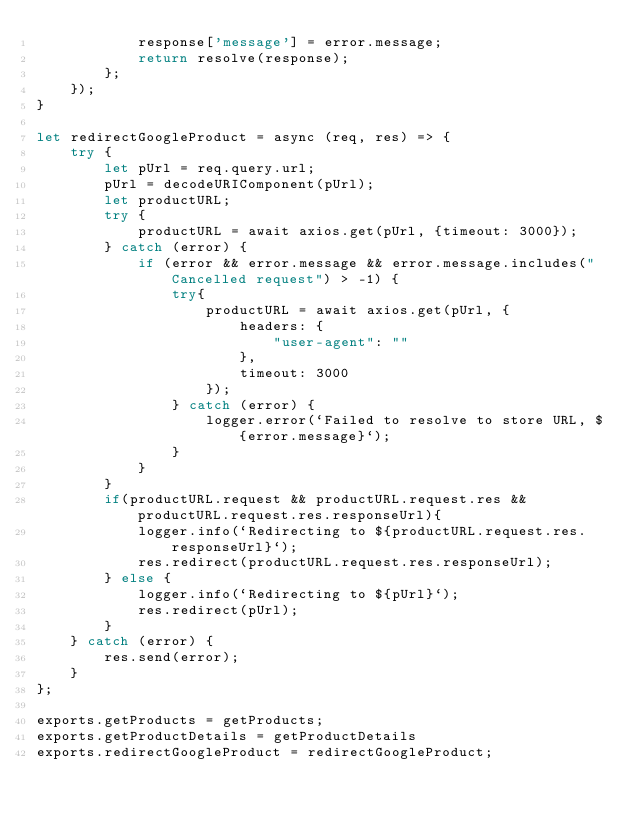<code> <loc_0><loc_0><loc_500><loc_500><_JavaScript_>            response['message'] = error.message;
            return resolve(response);
        };
    });
}

let redirectGoogleProduct = async (req, res) => {
    try {
        let pUrl = req.query.url;
        pUrl = decodeURIComponent(pUrl);
        let productURL;
        try {
            productURL = await axios.get(pUrl, {timeout: 3000});
        } catch (error) {
            if (error && error.message && error.message.includes("Cancelled request") > -1) {
                try{
                    productURL = await axios.get(pUrl, {
                        headers: {
                            "user-agent": ""
                        },
                        timeout: 3000
                    });
                } catch (error) {
                    logger.error(`Failed to resolve to store URL, ${error.message}`);
                }
            }
        }
        if(productURL.request && productURL.request.res && productURL.request.res.responseUrl){
            logger.info(`Redirecting to ${productURL.request.res.responseUrl}`);
            res.redirect(productURL.request.res.responseUrl);
        } else {
            logger.info(`Redirecting to ${pUrl}`);
            res.redirect(pUrl);
        }
    } catch (error) {
        res.send(error);
    }
};

exports.getProducts = getProducts;
exports.getProductDetails = getProductDetails
exports.redirectGoogleProduct = redirectGoogleProduct;</code> 